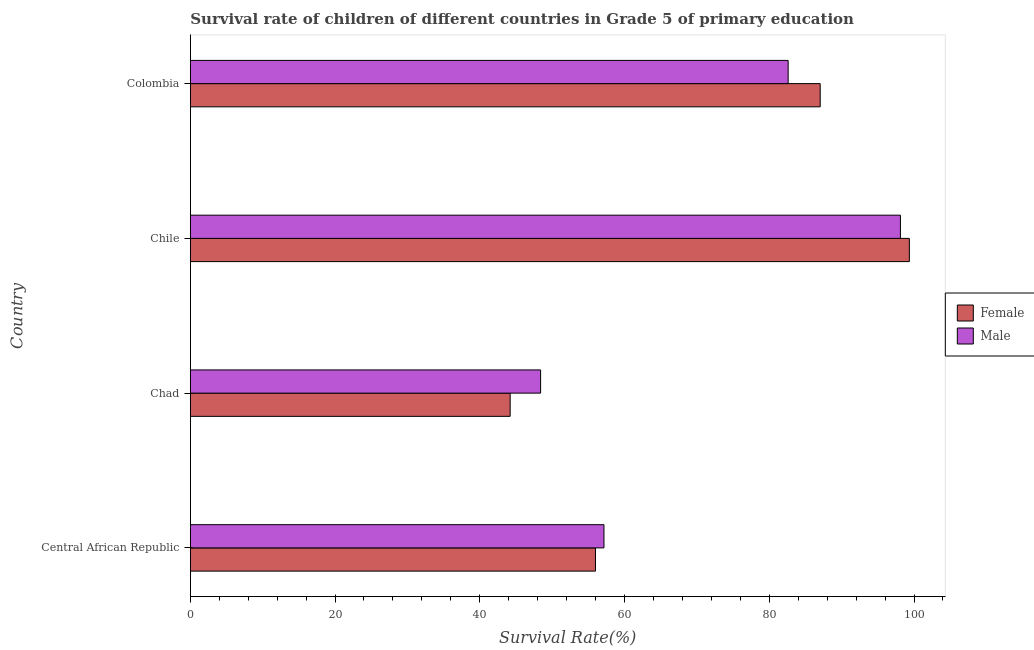How many different coloured bars are there?
Make the answer very short. 2. How many groups of bars are there?
Your answer should be compact. 4. Are the number of bars per tick equal to the number of legend labels?
Keep it short and to the point. Yes. How many bars are there on the 2nd tick from the bottom?
Provide a short and direct response. 2. What is the label of the 4th group of bars from the top?
Give a very brief answer. Central African Republic. What is the survival rate of female students in primary education in Chad?
Your answer should be compact. 44.2. Across all countries, what is the maximum survival rate of male students in primary education?
Offer a terse response. 98.12. Across all countries, what is the minimum survival rate of male students in primary education?
Offer a very short reply. 48.41. In which country was the survival rate of female students in primary education minimum?
Your answer should be compact. Chad. What is the total survival rate of male students in primary education in the graph?
Keep it short and to the point. 286.3. What is the difference between the survival rate of female students in primary education in Central African Republic and that in Chad?
Your response must be concise. 11.79. What is the difference between the survival rate of female students in primary education in Colombia and the survival rate of male students in primary education in Central African Republic?
Provide a succinct answer. 29.88. What is the average survival rate of female students in primary education per country?
Make the answer very short. 71.65. What is the difference between the survival rate of female students in primary education and survival rate of male students in primary education in Central African Republic?
Give a very brief answer. -1.17. In how many countries, is the survival rate of male students in primary education greater than 52 %?
Offer a very short reply. 3. What is the ratio of the survival rate of female students in primary education in Central African Republic to that in Chad?
Keep it short and to the point. 1.27. Is the difference between the survival rate of male students in primary education in Central African Republic and Colombia greater than the difference between the survival rate of female students in primary education in Central African Republic and Colombia?
Your answer should be very brief. Yes. What is the difference between the highest and the second highest survival rate of male students in primary education?
Your answer should be compact. 15.51. What is the difference between the highest and the lowest survival rate of female students in primary education?
Your response must be concise. 55.16. In how many countries, is the survival rate of male students in primary education greater than the average survival rate of male students in primary education taken over all countries?
Offer a very short reply. 2. What does the 2nd bar from the top in Chad represents?
Your response must be concise. Female. What is the difference between two consecutive major ticks on the X-axis?
Offer a terse response. 20. Are the values on the major ticks of X-axis written in scientific E-notation?
Your answer should be very brief. No. Does the graph contain any zero values?
Offer a very short reply. No. Does the graph contain grids?
Provide a short and direct response. No. Where does the legend appear in the graph?
Make the answer very short. Center right. What is the title of the graph?
Your answer should be very brief. Survival rate of children of different countries in Grade 5 of primary education. Does "Highest 10% of population" appear as one of the legend labels in the graph?
Ensure brevity in your answer.  No. What is the label or title of the X-axis?
Your answer should be compact. Survival Rate(%). What is the Survival Rate(%) in Female in Central African Republic?
Offer a very short reply. 55.99. What is the Survival Rate(%) in Male in Central African Republic?
Ensure brevity in your answer.  57.16. What is the Survival Rate(%) in Female in Chad?
Your response must be concise. 44.2. What is the Survival Rate(%) in Male in Chad?
Offer a very short reply. 48.41. What is the Survival Rate(%) in Female in Chile?
Make the answer very short. 99.36. What is the Survival Rate(%) of Male in Chile?
Offer a very short reply. 98.12. What is the Survival Rate(%) in Female in Colombia?
Your answer should be compact. 87.04. What is the Survival Rate(%) in Male in Colombia?
Give a very brief answer. 82.61. Across all countries, what is the maximum Survival Rate(%) of Female?
Give a very brief answer. 99.36. Across all countries, what is the maximum Survival Rate(%) of Male?
Your answer should be compact. 98.12. Across all countries, what is the minimum Survival Rate(%) of Female?
Your response must be concise. 44.2. Across all countries, what is the minimum Survival Rate(%) in Male?
Offer a terse response. 48.41. What is the total Survival Rate(%) in Female in the graph?
Your answer should be very brief. 286.58. What is the total Survival Rate(%) of Male in the graph?
Your answer should be very brief. 286.3. What is the difference between the Survival Rate(%) in Female in Central African Republic and that in Chad?
Provide a short and direct response. 11.79. What is the difference between the Survival Rate(%) in Male in Central African Republic and that in Chad?
Your response must be concise. 8.75. What is the difference between the Survival Rate(%) of Female in Central African Republic and that in Chile?
Your answer should be very brief. -43.37. What is the difference between the Survival Rate(%) in Male in Central African Republic and that in Chile?
Ensure brevity in your answer.  -40.96. What is the difference between the Survival Rate(%) in Female in Central African Republic and that in Colombia?
Make the answer very short. -31.05. What is the difference between the Survival Rate(%) of Male in Central African Republic and that in Colombia?
Keep it short and to the point. -25.45. What is the difference between the Survival Rate(%) in Female in Chad and that in Chile?
Your answer should be very brief. -55.16. What is the difference between the Survival Rate(%) of Male in Chad and that in Chile?
Your answer should be compact. -49.72. What is the difference between the Survival Rate(%) in Female in Chad and that in Colombia?
Your response must be concise. -42.84. What is the difference between the Survival Rate(%) of Male in Chad and that in Colombia?
Make the answer very short. -34.21. What is the difference between the Survival Rate(%) of Female in Chile and that in Colombia?
Your response must be concise. 12.32. What is the difference between the Survival Rate(%) in Male in Chile and that in Colombia?
Make the answer very short. 15.51. What is the difference between the Survival Rate(%) of Female in Central African Republic and the Survival Rate(%) of Male in Chad?
Provide a succinct answer. 7.58. What is the difference between the Survival Rate(%) in Female in Central African Republic and the Survival Rate(%) in Male in Chile?
Your answer should be compact. -42.14. What is the difference between the Survival Rate(%) of Female in Central African Republic and the Survival Rate(%) of Male in Colombia?
Provide a short and direct response. -26.62. What is the difference between the Survival Rate(%) of Female in Chad and the Survival Rate(%) of Male in Chile?
Offer a terse response. -53.93. What is the difference between the Survival Rate(%) of Female in Chad and the Survival Rate(%) of Male in Colombia?
Provide a succinct answer. -38.41. What is the difference between the Survival Rate(%) in Female in Chile and the Survival Rate(%) in Male in Colombia?
Offer a terse response. 16.75. What is the average Survival Rate(%) of Female per country?
Give a very brief answer. 71.65. What is the average Survival Rate(%) of Male per country?
Provide a succinct answer. 71.58. What is the difference between the Survival Rate(%) in Female and Survival Rate(%) in Male in Central African Republic?
Give a very brief answer. -1.17. What is the difference between the Survival Rate(%) in Female and Survival Rate(%) in Male in Chad?
Your answer should be compact. -4.21. What is the difference between the Survival Rate(%) in Female and Survival Rate(%) in Male in Chile?
Offer a very short reply. 1.23. What is the difference between the Survival Rate(%) in Female and Survival Rate(%) in Male in Colombia?
Your response must be concise. 4.43. What is the ratio of the Survival Rate(%) in Female in Central African Republic to that in Chad?
Your answer should be compact. 1.27. What is the ratio of the Survival Rate(%) in Male in Central African Republic to that in Chad?
Give a very brief answer. 1.18. What is the ratio of the Survival Rate(%) in Female in Central African Republic to that in Chile?
Offer a terse response. 0.56. What is the ratio of the Survival Rate(%) of Male in Central African Republic to that in Chile?
Ensure brevity in your answer.  0.58. What is the ratio of the Survival Rate(%) in Female in Central African Republic to that in Colombia?
Your answer should be very brief. 0.64. What is the ratio of the Survival Rate(%) in Male in Central African Republic to that in Colombia?
Your response must be concise. 0.69. What is the ratio of the Survival Rate(%) in Female in Chad to that in Chile?
Make the answer very short. 0.44. What is the ratio of the Survival Rate(%) in Male in Chad to that in Chile?
Ensure brevity in your answer.  0.49. What is the ratio of the Survival Rate(%) of Female in Chad to that in Colombia?
Offer a terse response. 0.51. What is the ratio of the Survival Rate(%) in Male in Chad to that in Colombia?
Your response must be concise. 0.59. What is the ratio of the Survival Rate(%) in Female in Chile to that in Colombia?
Offer a very short reply. 1.14. What is the ratio of the Survival Rate(%) of Male in Chile to that in Colombia?
Provide a succinct answer. 1.19. What is the difference between the highest and the second highest Survival Rate(%) in Female?
Your response must be concise. 12.32. What is the difference between the highest and the second highest Survival Rate(%) in Male?
Keep it short and to the point. 15.51. What is the difference between the highest and the lowest Survival Rate(%) in Female?
Provide a short and direct response. 55.16. What is the difference between the highest and the lowest Survival Rate(%) of Male?
Your answer should be very brief. 49.72. 